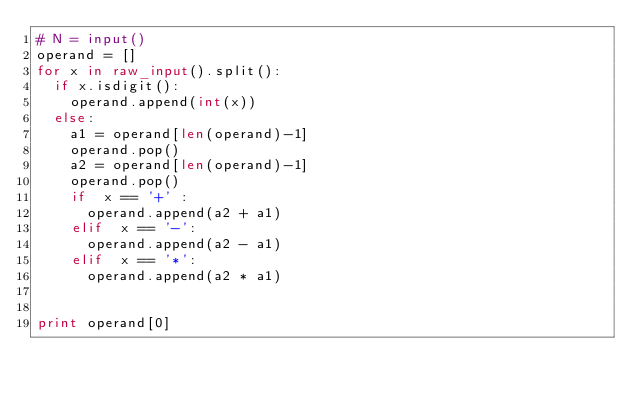<code> <loc_0><loc_0><loc_500><loc_500><_Python_># N = input()
operand = []
for x in raw_input().split():
  if x.isdigit():
    operand.append(int(x))
  else:
    a1 = operand[len(operand)-1]
    operand.pop()
    a2 = operand[len(operand)-1]
    operand.pop()
    if  x == '+' :
      operand.append(a2 + a1)
    elif  x == '-':
      operand.append(a2 - a1)
    elif  x == '*':
      operand.append(a2 * a1)


print operand[0]
  </code> 